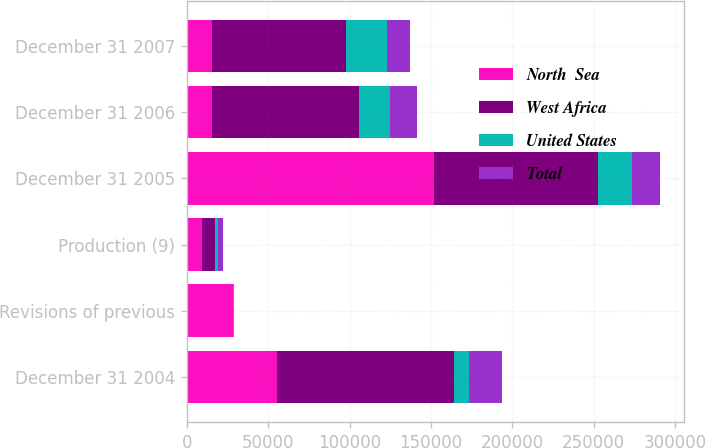Convert chart. <chart><loc_0><loc_0><loc_500><loc_500><stacked_bar_chart><ecel><fcel>December 31 2004<fcel>Revisions of previous<fcel>Production (9)<fcel>December 31 2005<fcel>December 31 2006<fcel>December 31 2007<nl><fcel>North  Sea<fcel>55066<fcel>27998<fcel>9468<fcel>151656<fcel>15516<fcel>15516<nl><fcel>West Africa<fcel>108730<fcel>229<fcel>7675<fcel>100935<fcel>90296<fcel>82220<nl><fcel>United States<fcel>9336<fcel>776<fcel>1964<fcel>20605<fcel>18852<fcel>25158<nl><fcel>Total<fcel>20332<fcel>132<fcel>2866<fcel>17634<fcel>16800<fcel>14232<nl></chart> 